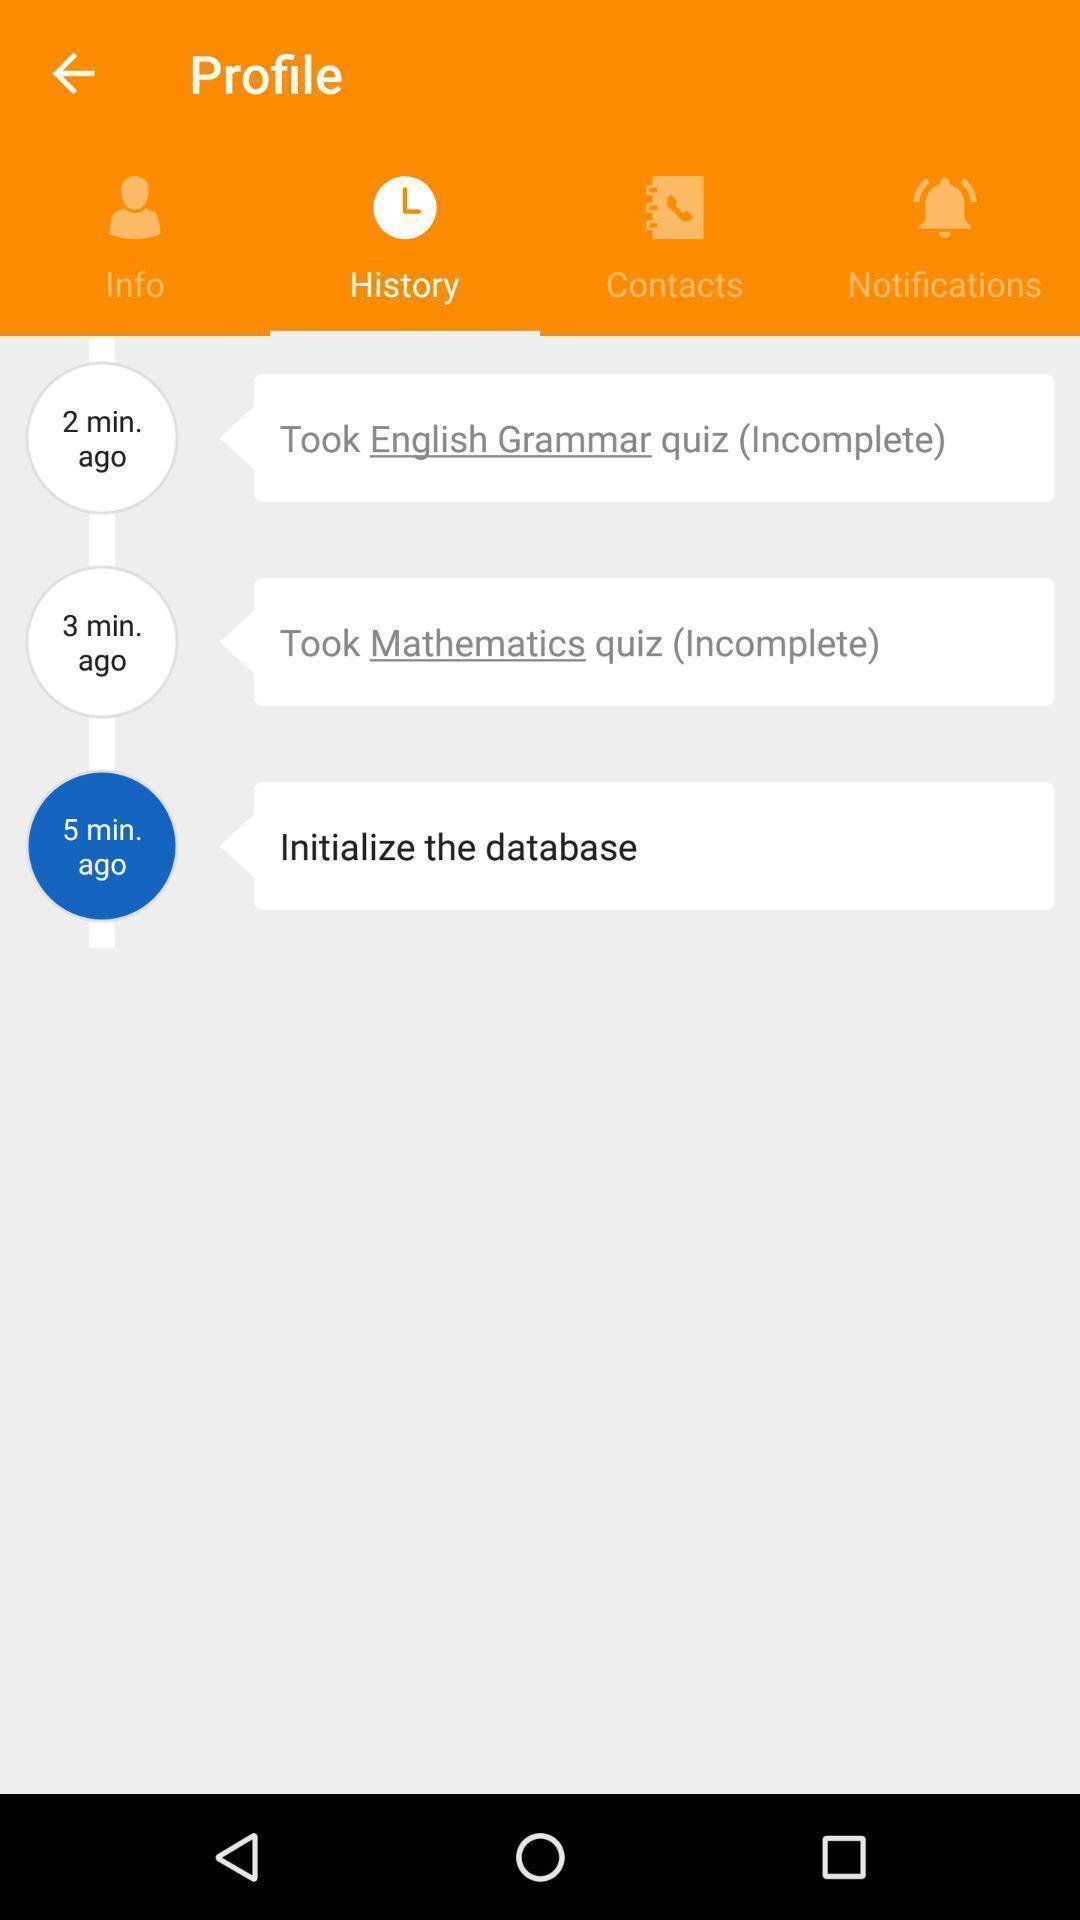Summarize the information in this screenshot. Screen page displaying different options. 